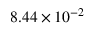<formula> <loc_0><loc_0><loc_500><loc_500>8 . 4 4 \times 1 0 ^ { - 2 }</formula> 